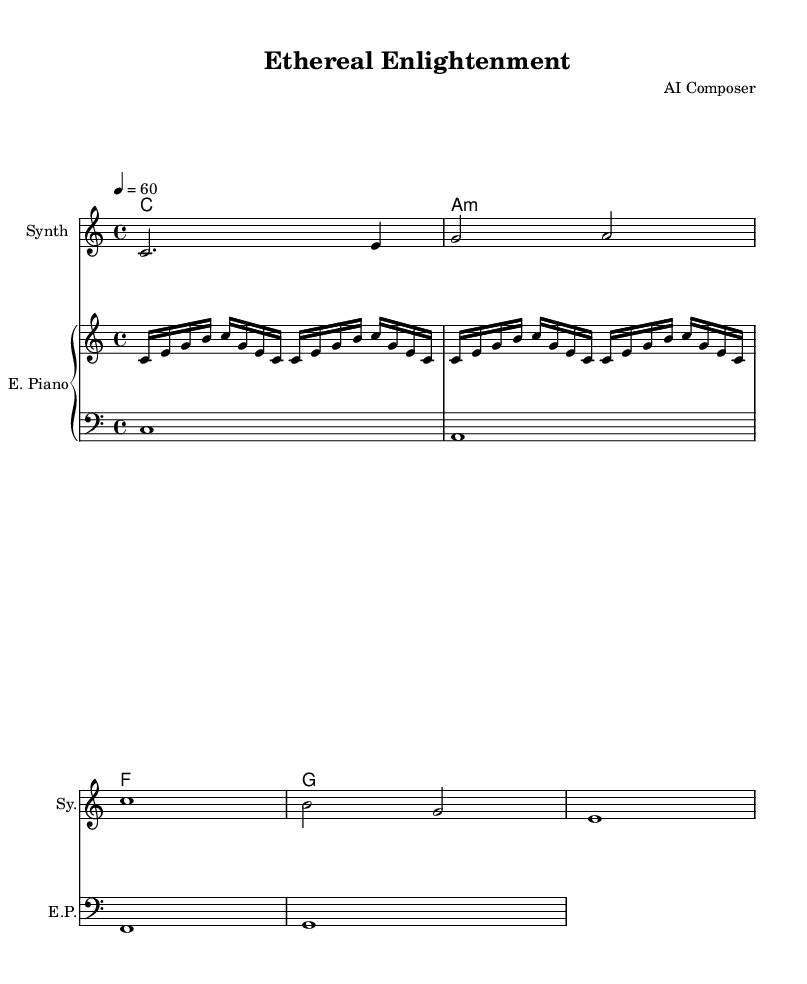What is the key signature of this music? The key signature is indicated in the global section, and it shows that the piece is in C major, which has no sharps or flats.
Answer: C major What is the time signature? The time signature is specified in the global section as 4/4, which indicates four beats per measure.
Answer: 4/4 What is the tempo marking? The tempo marking is provided in the global section with a metronome mark of quarter note = 60 beats per minute.
Answer: 60 What is the instrument name for the melody line? The melody is notated under a staff named "Synth," which is indicated in the score section.
Answer: Synth Which chord is played in the first measure of harmony? The first measure of harmonies shows a C major chord, represented by the letter "c" in chord notation.
Answer: C How many measures of melody are there in total? The melody consists of five distinct measures, each separated by a barline in the staff notation.
Answer: 5 What type of musical piece is this? The piece is described as an ambient electronic composition, characterized by serene and meditative qualities commonly found in spiritual practices.
Answer: Ambient electronic composition 